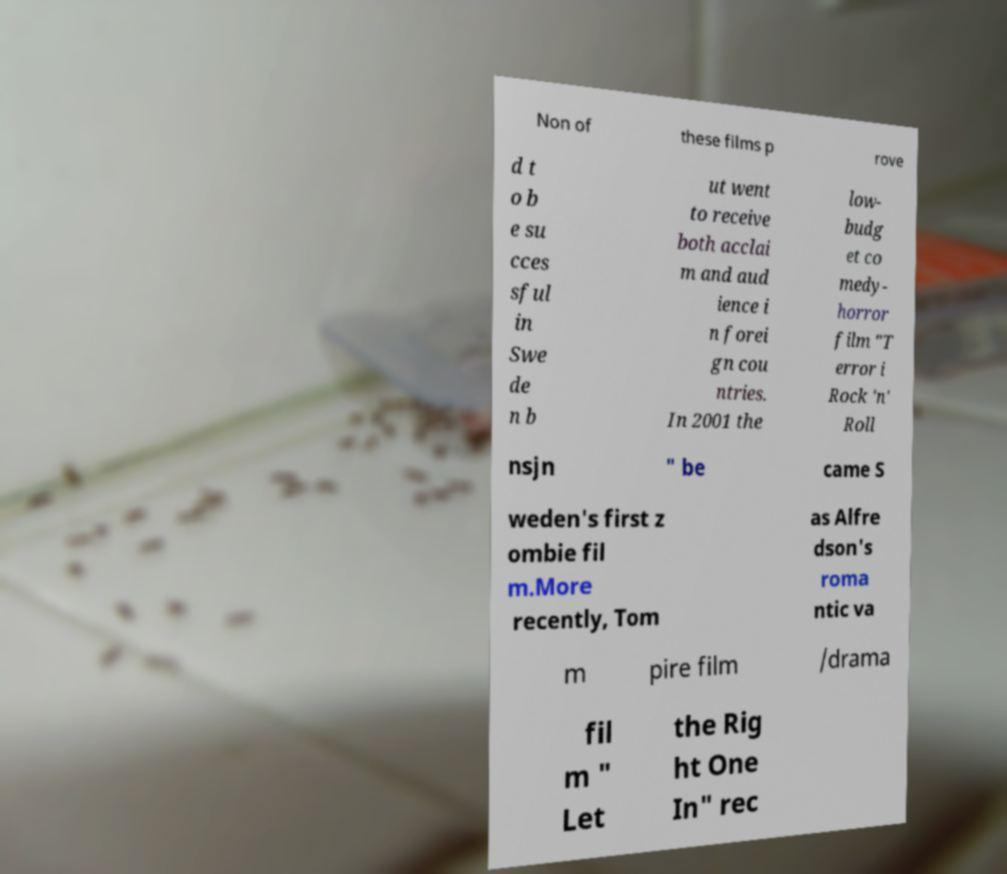Can you accurately transcribe the text from the provided image for me? Non of these films p rove d t o b e su cces sful in Swe de n b ut went to receive both acclai m and aud ience i n forei gn cou ntries. In 2001 the low- budg et co medy- horror film "T error i Rock 'n' Roll nsjn " be came S weden's first z ombie fil m.More recently, Tom as Alfre dson's roma ntic va m pire film /drama fil m " Let the Rig ht One In" rec 